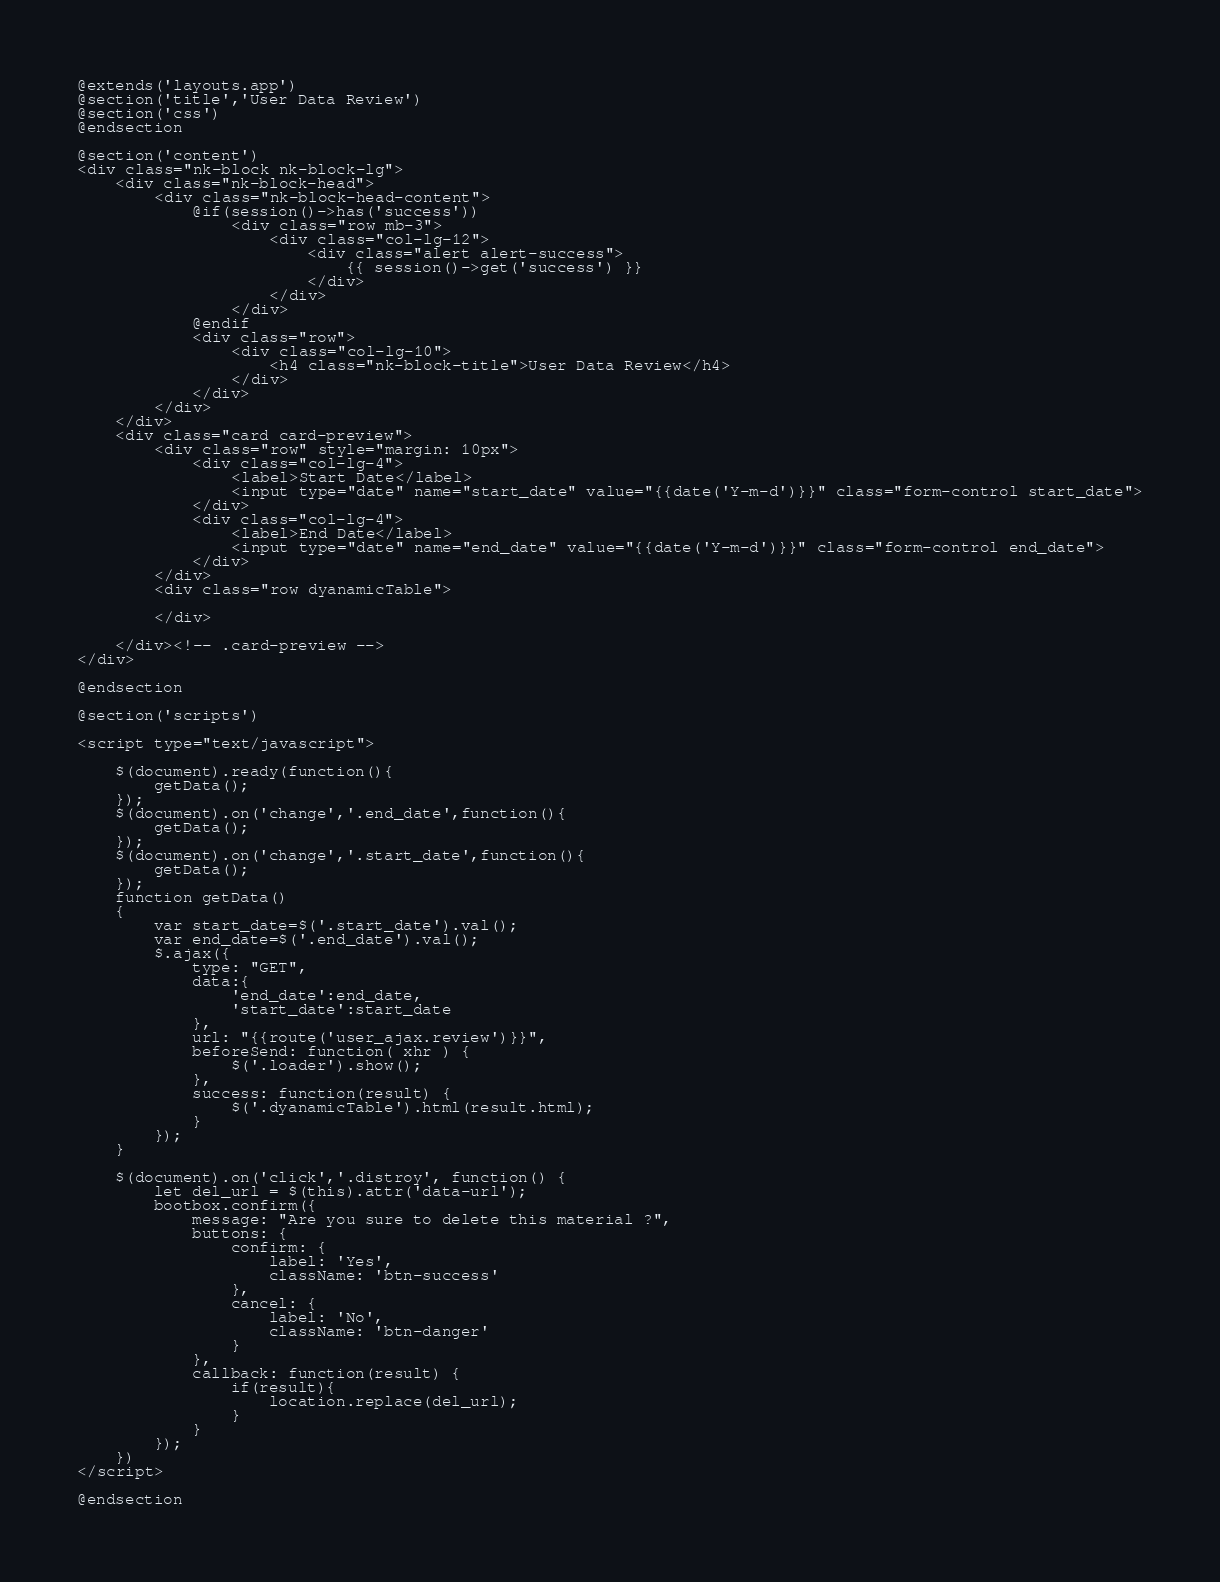Convert code to text. <code><loc_0><loc_0><loc_500><loc_500><_PHP_>@extends('layouts.app')
@section('title','User Data Review')
@section('css')
@endsection

@section('content')
<div class="nk-block nk-block-lg">
    <div class="nk-block-head">
        <div class="nk-block-head-content">
        	@if(session()->has('success'))
        		<div class="row mb-3">
        			<div class="col-lg-12">
					    <div class="alert alert-success">
					        {{ session()->get('success') }}
					    </div>
					</div>
				</div>
			@endif
        	<div class="row">
        		<div class="col-lg-10">
            		<h4 class="nk-block-title">User Data Review</h4>
            	</div>
            </div>
        </div>
    </div>
    <div class="card card-preview">
        <div class="row" style="margin: 10px">
            <div class="col-lg-4">    
                <label>Start Date</label>
                <input type="date" name="start_date" value="{{date('Y-m-d')}}" class="form-control start_date">
            </div>
            <div class="col-lg-4">
                <label>End Date</label>
                <input type="date" name="end_date" value="{{date('Y-m-d')}}" class="form-control end_date">
            </div>    
        </div>
        <div class="row dyanamicTable">
            
        </div>
            
    </div><!-- .card-preview -->
</div>

@endsection

@section('scripts')

<script type="text/javascript">

    $(document).ready(function(){
        getData();
    });
    $(document).on('change','.end_date',function(){
        getData();
    });
    $(document).on('change','.start_date',function(){
        getData();
    });
    function getData()
    {
        var start_date=$('.start_date').val();
        var end_date=$('.end_date').val();
        $.ajax({
            type: "GET",
            data:{
                'end_date':end_date,
                'start_date':start_date
            },
            url: "{{route('user_ajax.review')}}",
            beforeSend: function( xhr ) {
                $('.loader').show();
            },
            success: function(result) {
                $('.dyanamicTable').html(result.html);
            }
        });
    }

	$(document).on('click','.distroy', function() {
	    let del_url = $(this).attr('data-url');
	    bootbox.confirm({
	        message: "Are you sure to delete this material ?",
	        buttons: {
	            confirm: {
	                label: 'Yes',
	                className: 'btn-success'
	            },
	            cancel: {
	                label: 'No',
	                className: 'btn-danger'
	            }
	        },
	        callback: function(result) {
	            if(result){
	                location.replace(del_url);
	            }
	        }
	    });
	})
</script>

@endsection</code> 